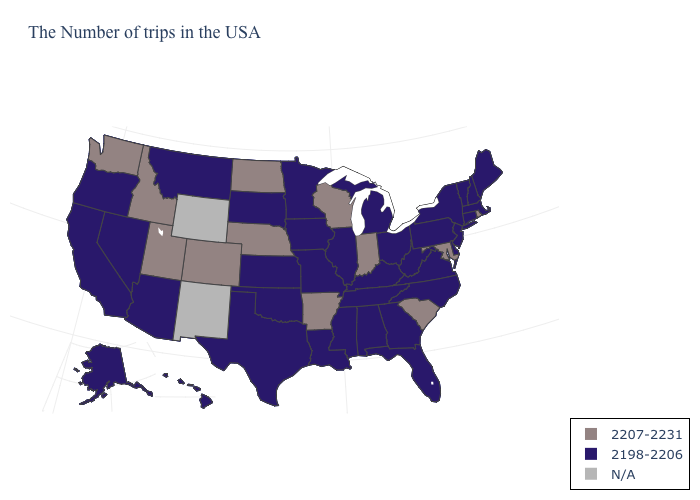Name the states that have a value in the range 2198-2206?
Concise answer only. Maine, Massachusetts, New Hampshire, Vermont, Connecticut, New York, New Jersey, Delaware, Pennsylvania, Virginia, North Carolina, West Virginia, Ohio, Florida, Georgia, Michigan, Kentucky, Alabama, Tennessee, Illinois, Mississippi, Louisiana, Missouri, Minnesota, Iowa, Kansas, Oklahoma, Texas, South Dakota, Montana, Arizona, Nevada, California, Oregon, Alaska, Hawaii. What is the value of Massachusetts?
Give a very brief answer. 2198-2206. Name the states that have a value in the range N/A?
Answer briefly. Wyoming, New Mexico. Name the states that have a value in the range N/A?
Quick response, please. Wyoming, New Mexico. Which states have the lowest value in the MidWest?
Quick response, please. Ohio, Michigan, Illinois, Missouri, Minnesota, Iowa, Kansas, South Dakota. Among the states that border Nebraska , does Colorado have the highest value?
Concise answer only. Yes. Does Washington have the lowest value in the USA?
Quick response, please. No. What is the value of Minnesota?
Write a very short answer. 2198-2206. Which states hav the highest value in the West?
Be succinct. Colorado, Utah, Idaho, Washington. Name the states that have a value in the range 2198-2206?
Concise answer only. Maine, Massachusetts, New Hampshire, Vermont, Connecticut, New York, New Jersey, Delaware, Pennsylvania, Virginia, North Carolina, West Virginia, Ohio, Florida, Georgia, Michigan, Kentucky, Alabama, Tennessee, Illinois, Mississippi, Louisiana, Missouri, Minnesota, Iowa, Kansas, Oklahoma, Texas, South Dakota, Montana, Arizona, Nevada, California, Oregon, Alaska, Hawaii. Among the states that border Oregon , does California have the lowest value?
Give a very brief answer. Yes. 